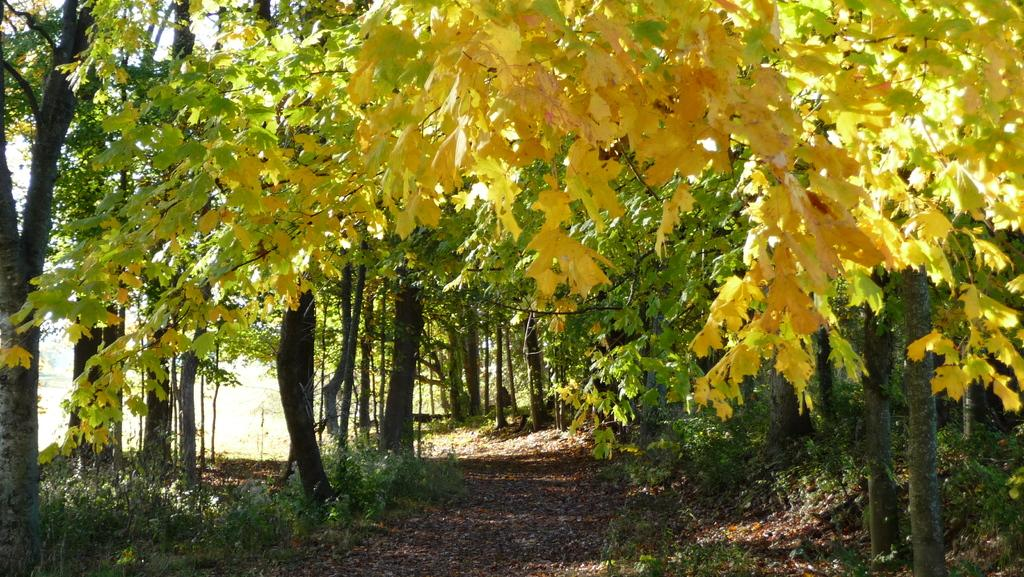What can be seen under the plants and trees in the image? The ground is visible in the image. What type of vegetation is present in the image? There are plants and trees in the image. What else can be found on the ground in the image? Dry leaves are present in the image. What type of vacation is the governor planning based on the image? There is no information about a governor or a vacation in the image. The image only shows the ground, plants, trees, and dry leaves. 